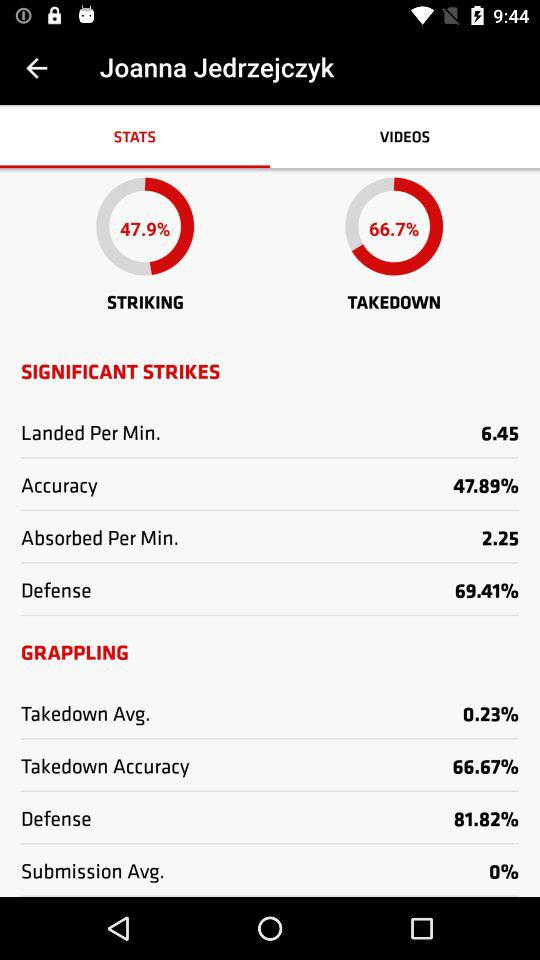How much is the takedown? The takedown is 66.7%. 